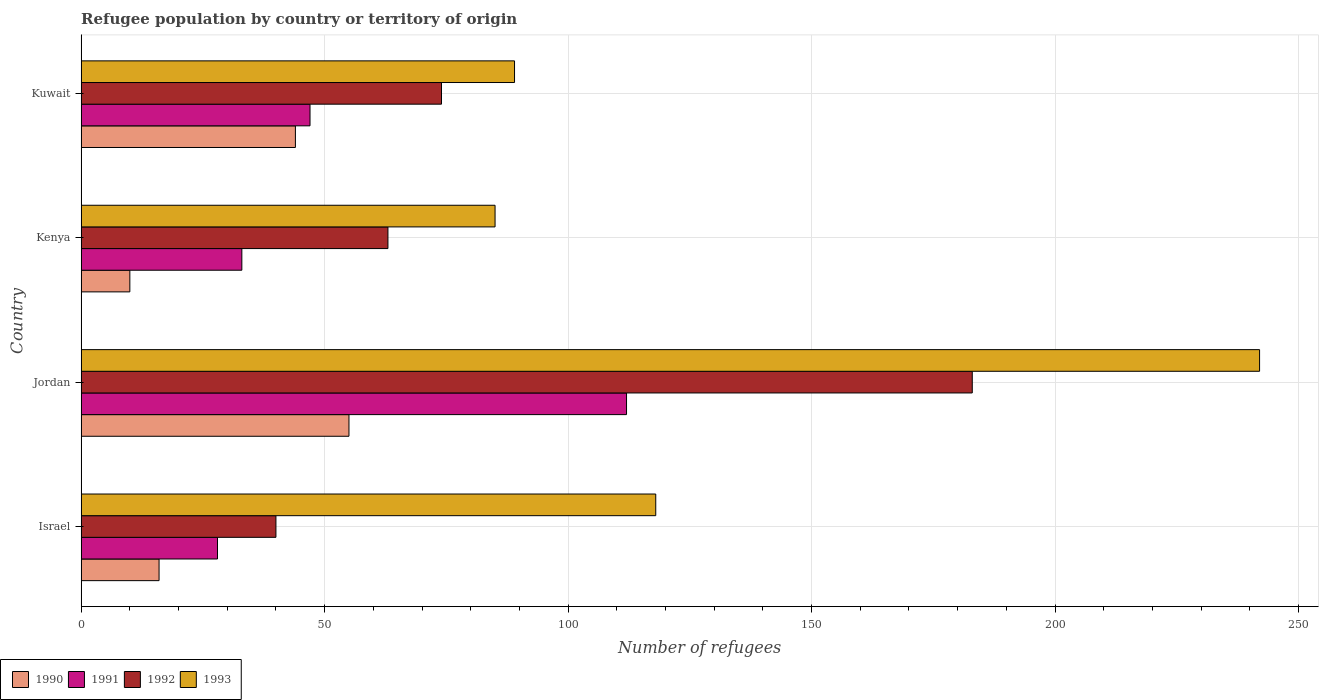How many different coloured bars are there?
Keep it short and to the point. 4. How many bars are there on the 4th tick from the bottom?
Provide a short and direct response. 4. What is the label of the 4th group of bars from the top?
Provide a succinct answer. Israel. In how many cases, is the number of bars for a given country not equal to the number of legend labels?
Ensure brevity in your answer.  0. Across all countries, what is the maximum number of refugees in 1993?
Give a very brief answer. 242. Across all countries, what is the minimum number of refugees in 1991?
Offer a terse response. 28. In which country was the number of refugees in 1993 maximum?
Your response must be concise. Jordan. In which country was the number of refugees in 1993 minimum?
Offer a terse response. Kenya. What is the total number of refugees in 1990 in the graph?
Provide a short and direct response. 125. What is the difference between the number of refugees in 1992 in Israel and that in Kuwait?
Offer a terse response. -34. What is the difference between the number of refugees in 1992 in Jordan and the number of refugees in 1990 in Kuwait?
Your response must be concise. 139. What is the difference between the number of refugees in 1992 and number of refugees in 1991 in Israel?
Ensure brevity in your answer.  12. In how many countries, is the number of refugees in 1991 greater than 180 ?
Provide a succinct answer. 0. What is the ratio of the number of refugees in 1992 in Jordan to that in Kuwait?
Offer a very short reply. 2.47. Is the number of refugees in 1993 in Israel less than that in Kuwait?
Your response must be concise. No. What is the difference between the highest and the second highest number of refugees in 1992?
Your response must be concise. 109. What is the difference between the highest and the lowest number of refugees in 1990?
Keep it short and to the point. 45. Is the sum of the number of refugees in 1990 in Jordan and Kuwait greater than the maximum number of refugees in 1992 across all countries?
Keep it short and to the point. No. Is it the case that in every country, the sum of the number of refugees in 1990 and number of refugees in 1991 is greater than the sum of number of refugees in 1993 and number of refugees in 1992?
Offer a terse response. No. What does the 4th bar from the bottom in Kenya represents?
Provide a short and direct response. 1993. Is it the case that in every country, the sum of the number of refugees in 1991 and number of refugees in 1993 is greater than the number of refugees in 1992?
Your response must be concise. Yes. Are all the bars in the graph horizontal?
Provide a short and direct response. Yes. What is the difference between two consecutive major ticks on the X-axis?
Your response must be concise. 50. Does the graph contain grids?
Provide a succinct answer. Yes. How many legend labels are there?
Make the answer very short. 4. How are the legend labels stacked?
Keep it short and to the point. Horizontal. What is the title of the graph?
Your answer should be very brief. Refugee population by country or territory of origin. What is the label or title of the X-axis?
Offer a very short reply. Number of refugees. What is the Number of refugees in 1992 in Israel?
Ensure brevity in your answer.  40. What is the Number of refugees of 1993 in Israel?
Offer a terse response. 118. What is the Number of refugees in 1991 in Jordan?
Offer a terse response. 112. What is the Number of refugees in 1992 in Jordan?
Make the answer very short. 183. What is the Number of refugees of 1993 in Jordan?
Your response must be concise. 242. What is the Number of refugees in 1992 in Kenya?
Ensure brevity in your answer.  63. What is the Number of refugees in 1993 in Kenya?
Offer a very short reply. 85. What is the Number of refugees of 1990 in Kuwait?
Your answer should be very brief. 44. What is the Number of refugees in 1991 in Kuwait?
Provide a short and direct response. 47. What is the Number of refugees of 1992 in Kuwait?
Ensure brevity in your answer.  74. What is the Number of refugees in 1993 in Kuwait?
Your response must be concise. 89. Across all countries, what is the maximum Number of refugees in 1990?
Provide a short and direct response. 55. Across all countries, what is the maximum Number of refugees of 1991?
Keep it short and to the point. 112. Across all countries, what is the maximum Number of refugees in 1992?
Provide a short and direct response. 183. Across all countries, what is the maximum Number of refugees of 1993?
Ensure brevity in your answer.  242. Across all countries, what is the minimum Number of refugees of 1990?
Your answer should be very brief. 10. Across all countries, what is the minimum Number of refugees in 1992?
Your response must be concise. 40. What is the total Number of refugees of 1990 in the graph?
Offer a terse response. 125. What is the total Number of refugees of 1991 in the graph?
Offer a terse response. 220. What is the total Number of refugees of 1992 in the graph?
Keep it short and to the point. 360. What is the total Number of refugees in 1993 in the graph?
Offer a very short reply. 534. What is the difference between the Number of refugees in 1990 in Israel and that in Jordan?
Offer a very short reply. -39. What is the difference between the Number of refugees in 1991 in Israel and that in Jordan?
Ensure brevity in your answer.  -84. What is the difference between the Number of refugees in 1992 in Israel and that in Jordan?
Your answer should be compact. -143. What is the difference between the Number of refugees of 1993 in Israel and that in Jordan?
Offer a terse response. -124. What is the difference between the Number of refugees in 1990 in Israel and that in Kenya?
Your response must be concise. 6. What is the difference between the Number of refugees of 1991 in Israel and that in Kenya?
Ensure brevity in your answer.  -5. What is the difference between the Number of refugees of 1992 in Israel and that in Kenya?
Give a very brief answer. -23. What is the difference between the Number of refugees of 1990 in Israel and that in Kuwait?
Keep it short and to the point. -28. What is the difference between the Number of refugees in 1992 in Israel and that in Kuwait?
Offer a very short reply. -34. What is the difference between the Number of refugees in 1993 in Israel and that in Kuwait?
Your response must be concise. 29. What is the difference between the Number of refugees in 1990 in Jordan and that in Kenya?
Ensure brevity in your answer.  45. What is the difference between the Number of refugees of 1991 in Jordan and that in Kenya?
Make the answer very short. 79. What is the difference between the Number of refugees in 1992 in Jordan and that in Kenya?
Give a very brief answer. 120. What is the difference between the Number of refugees in 1993 in Jordan and that in Kenya?
Keep it short and to the point. 157. What is the difference between the Number of refugees in 1992 in Jordan and that in Kuwait?
Ensure brevity in your answer.  109. What is the difference between the Number of refugees of 1993 in Jordan and that in Kuwait?
Provide a short and direct response. 153. What is the difference between the Number of refugees in 1990 in Kenya and that in Kuwait?
Ensure brevity in your answer.  -34. What is the difference between the Number of refugees of 1991 in Kenya and that in Kuwait?
Give a very brief answer. -14. What is the difference between the Number of refugees of 1990 in Israel and the Number of refugees of 1991 in Jordan?
Provide a short and direct response. -96. What is the difference between the Number of refugees of 1990 in Israel and the Number of refugees of 1992 in Jordan?
Give a very brief answer. -167. What is the difference between the Number of refugees in 1990 in Israel and the Number of refugees in 1993 in Jordan?
Make the answer very short. -226. What is the difference between the Number of refugees of 1991 in Israel and the Number of refugees of 1992 in Jordan?
Make the answer very short. -155. What is the difference between the Number of refugees in 1991 in Israel and the Number of refugees in 1993 in Jordan?
Provide a succinct answer. -214. What is the difference between the Number of refugees of 1992 in Israel and the Number of refugees of 1993 in Jordan?
Provide a short and direct response. -202. What is the difference between the Number of refugees of 1990 in Israel and the Number of refugees of 1991 in Kenya?
Your answer should be very brief. -17. What is the difference between the Number of refugees in 1990 in Israel and the Number of refugees in 1992 in Kenya?
Make the answer very short. -47. What is the difference between the Number of refugees of 1990 in Israel and the Number of refugees of 1993 in Kenya?
Make the answer very short. -69. What is the difference between the Number of refugees of 1991 in Israel and the Number of refugees of 1992 in Kenya?
Your response must be concise. -35. What is the difference between the Number of refugees in 1991 in Israel and the Number of refugees in 1993 in Kenya?
Offer a terse response. -57. What is the difference between the Number of refugees in 1992 in Israel and the Number of refugees in 1993 in Kenya?
Provide a short and direct response. -45. What is the difference between the Number of refugees of 1990 in Israel and the Number of refugees of 1991 in Kuwait?
Provide a short and direct response. -31. What is the difference between the Number of refugees in 1990 in Israel and the Number of refugees in 1992 in Kuwait?
Keep it short and to the point. -58. What is the difference between the Number of refugees in 1990 in Israel and the Number of refugees in 1993 in Kuwait?
Your answer should be very brief. -73. What is the difference between the Number of refugees of 1991 in Israel and the Number of refugees of 1992 in Kuwait?
Your answer should be compact. -46. What is the difference between the Number of refugees in 1991 in Israel and the Number of refugees in 1993 in Kuwait?
Provide a short and direct response. -61. What is the difference between the Number of refugees in 1992 in Israel and the Number of refugees in 1993 in Kuwait?
Give a very brief answer. -49. What is the difference between the Number of refugees in 1990 in Jordan and the Number of refugees in 1993 in Kenya?
Offer a very short reply. -30. What is the difference between the Number of refugees in 1992 in Jordan and the Number of refugees in 1993 in Kenya?
Give a very brief answer. 98. What is the difference between the Number of refugees of 1990 in Jordan and the Number of refugees of 1991 in Kuwait?
Keep it short and to the point. 8. What is the difference between the Number of refugees in 1990 in Jordan and the Number of refugees in 1993 in Kuwait?
Offer a very short reply. -34. What is the difference between the Number of refugees of 1991 in Jordan and the Number of refugees of 1993 in Kuwait?
Your answer should be compact. 23. What is the difference between the Number of refugees of 1992 in Jordan and the Number of refugees of 1993 in Kuwait?
Your answer should be compact. 94. What is the difference between the Number of refugees of 1990 in Kenya and the Number of refugees of 1991 in Kuwait?
Your answer should be very brief. -37. What is the difference between the Number of refugees of 1990 in Kenya and the Number of refugees of 1992 in Kuwait?
Your response must be concise. -64. What is the difference between the Number of refugees of 1990 in Kenya and the Number of refugees of 1993 in Kuwait?
Keep it short and to the point. -79. What is the difference between the Number of refugees of 1991 in Kenya and the Number of refugees of 1992 in Kuwait?
Your response must be concise. -41. What is the difference between the Number of refugees in 1991 in Kenya and the Number of refugees in 1993 in Kuwait?
Your response must be concise. -56. What is the difference between the Number of refugees of 1992 in Kenya and the Number of refugees of 1993 in Kuwait?
Provide a succinct answer. -26. What is the average Number of refugees of 1990 per country?
Your answer should be compact. 31.25. What is the average Number of refugees of 1992 per country?
Provide a succinct answer. 90. What is the average Number of refugees in 1993 per country?
Give a very brief answer. 133.5. What is the difference between the Number of refugees of 1990 and Number of refugees of 1991 in Israel?
Ensure brevity in your answer.  -12. What is the difference between the Number of refugees in 1990 and Number of refugees in 1992 in Israel?
Keep it short and to the point. -24. What is the difference between the Number of refugees in 1990 and Number of refugees in 1993 in Israel?
Keep it short and to the point. -102. What is the difference between the Number of refugees of 1991 and Number of refugees of 1992 in Israel?
Offer a terse response. -12. What is the difference between the Number of refugees in 1991 and Number of refugees in 1993 in Israel?
Give a very brief answer. -90. What is the difference between the Number of refugees of 1992 and Number of refugees of 1993 in Israel?
Offer a very short reply. -78. What is the difference between the Number of refugees in 1990 and Number of refugees in 1991 in Jordan?
Your answer should be very brief. -57. What is the difference between the Number of refugees of 1990 and Number of refugees of 1992 in Jordan?
Provide a short and direct response. -128. What is the difference between the Number of refugees in 1990 and Number of refugees in 1993 in Jordan?
Make the answer very short. -187. What is the difference between the Number of refugees in 1991 and Number of refugees in 1992 in Jordan?
Keep it short and to the point. -71. What is the difference between the Number of refugees of 1991 and Number of refugees of 1993 in Jordan?
Give a very brief answer. -130. What is the difference between the Number of refugees of 1992 and Number of refugees of 1993 in Jordan?
Ensure brevity in your answer.  -59. What is the difference between the Number of refugees in 1990 and Number of refugees in 1991 in Kenya?
Give a very brief answer. -23. What is the difference between the Number of refugees of 1990 and Number of refugees of 1992 in Kenya?
Offer a terse response. -53. What is the difference between the Number of refugees of 1990 and Number of refugees of 1993 in Kenya?
Your answer should be compact. -75. What is the difference between the Number of refugees in 1991 and Number of refugees in 1993 in Kenya?
Your answer should be compact. -52. What is the difference between the Number of refugees in 1990 and Number of refugees in 1992 in Kuwait?
Provide a short and direct response. -30. What is the difference between the Number of refugees in 1990 and Number of refugees in 1993 in Kuwait?
Offer a terse response. -45. What is the difference between the Number of refugees of 1991 and Number of refugees of 1992 in Kuwait?
Keep it short and to the point. -27. What is the difference between the Number of refugees in 1991 and Number of refugees in 1993 in Kuwait?
Provide a succinct answer. -42. What is the ratio of the Number of refugees of 1990 in Israel to that in Jordan?
Offer a very short reply. 0.29. What is the ratio of the Number of refugees of 1991 in Israel to that in Jordan?
Your answer should be compact. 0.25. What is the ratio of the Number of refugees in 1992 in Israel to that in Jordan?
Provide a short and direct response. 0.22. What is the ratio of the Number of refugees of 1993 in Israel to that in Jordan?
Your response must be concise. 0.49. What is the ratio of the Number of refugees in 1991 in Israel to that in Kenya?
Your answer should be compact. 0.85. What is the ratio of the Number of refugees of 1992 in Israel to that in Kenya?
Ensure brevity in your answer.  0.63. What is the ratio of the Number of refugees in 1993 in Israel to that in Kenya?
Ensure brevity in your answer.  1.39. What is the ratio of the Number of refugees of 1990 in Israel to that in Kuwait?
Keep it short and to the point. 0.36. What is the ratio of the Number of refugees of 1991 in Israel to that in Kuwait?
Your response must be concise. 0.6. What is the ratio of the Number of refugees in 1992 in Israel to that in Kuwait?
Your response must be concise. 0.54. What is the ratio of the Number of refugees in 1993 in Israel to that in Kuwait?
Provide a short and direct response. 1.33. What is the ratio of the Number of refugees of 1991 in Jordan to that in Kenya?
Offer a very short reply. 3.39. What is the ratio of the Number of refugees of 1992 in Jordan to that in Kenya?
Your answer should be compact. 2.9. What is the ratio of the Number of refugees of 1993 in Jordan to that in Kenya?
Provide a short and direct response. 2.85. What is the ratio of the Number of refugees in 1990 in Jordan to that in Kuwait?
Give a very brief answer. 1.25. What is the ratio of the Number of refugees of 1991 in Jordan to that in Kuwait?
Your answer should be very brief. 2.38. What is the ratio of the Number of refugees of 1992 in Jordan to that in Kuwait?
Offer a very short reply. 2.47. What is the ratio of the Number of refugees of 1993 in Jordan to that in Kuwait?
Offer a very short reply. 2.72. What is the ratio of the Number of refugees in 1990 in Kenya to that in Kuwait?
Make the answer very short. 0.23. What is the ratio of the Number of refugees of 1991 in Kenya to that in Kuwait?
Offer a very short reply. 0.7. What is the ratio of the Number of refugees in 1992 in Kenya to that in Kuwait?
Your answer should be compact. 0.85. What is the ratio of the Number of refugees in 1993 in Kenya to that in Kuwait?
Provide a short and direct response. 0.96. What is the difference between the highest and the second highest Number of refugees in 1990?
Offer a terse response. 11. What is the difference between the highest and the second highest Number of refugees in 1991?
Keep it short and to the point. 65. What is the difference between the highest and the second highest Number of refugees in 1992?
Make the answer very short. 109. What is the difference between the highest and the second highest Number of refugees in 1993?
Offer a terse response. 124. What is the difference between the highest and the lowest Number of refugees in 1990?
Give a very brief answer. 45. What is the difference between the highest and the lowest Number of refugees in 1992?
Offer a very short reply. 143. What is the difference between the highest and the lowest Number of refugees of 1993?
Give a very brief answer. 157. 